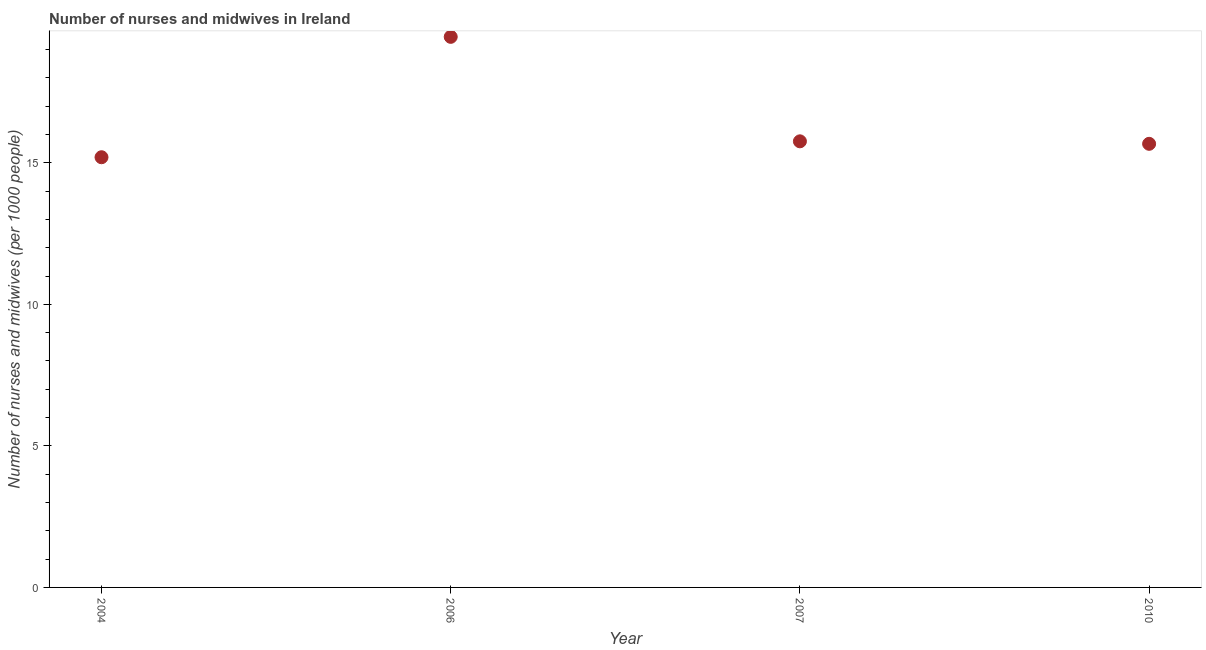What is the number of nurses and midwives in 2007?
Offer a terse response. 15.76. Across all years, what is the maximum number of nurses and midwives?
Ensure brevity in your answer.  19.45. Across all years, what is the minimum number of nurses and midwives?
Your answer should be very brief. 15.2. In which year was the number of nurses and midwives maximum?
Your answer should be very brief. 2006. What is the sum of the number of nurses and midwives?
Ensure brevity in your answer.  66.08. What is the difference between the number of nurses and midwives in 2004 and 2006?
Offer a very short reply. -4.25. What is the average number of nurses and midwives per year?
Ensure brevity in your answer.  16.52. What is the median number of nurses and midwives?
Make the answer very short. 15.71. What is the ratio of the number of nurses and midwives in 2006 to that in 2010?
Offer a very short reply. 1.24. Is the difference between the number of nurses and midwives in 2006 and 2007 greater than the difference between any two years?
Offer a very short reply. No. What is the difference between the highest and the second highest number of nurses and midwives?
Make the answer very short. 3.69. What is the difference between the highest and the lowest number of nurses and midwives?
Your response must be concise. 4.25. How many dotlines are there?
Ensure brevity in your answer.  1. What is the difference between two consecutive major ticks on the Y-axis?
Give a very brief answer. 5. Does the graph contain any zero values?
Make the answer very short. No. What is the title of the graph?
Ensure brevity in your answer.  Number of nurses and midwives in Ireland. What is the label or title of the Y-axis?
Your answer should be very brief. Number of nurses and midwives (per 1000 people). What is the Number of nurses and midwives (per 1000 people) in 2004?
Provide a succinct answer. 15.2. What is the Number of nurses and midwives (per 1000 people) in 2006?
Make the answer very short. 19.45. What is the Number of nurses and midwives (per 1000 people) in 2007?
Keep it short and to the point. 15.76. What is the Number of nurses and midwives (per 1000 people) in 2010?
Ensure brevity in your answer.  15.67. What is the difference between the Number of nurses and midwives (per 1000 people) in 2004 and 2006?
Your answer should be compact. -4.25. What is the difference between the Number of nurses and midwives (per 1000 people) in 2004 and 2007?
Your response must be concise. -0.56. What is the difference between the Number of nurses and midwives (per 1000 people) in 2004 and 2010?
Provide a succinct answer. -0.47. What is the difference between the Number of nurses and midwives (per 1000 people) in 2006 and 2007?
Provide a succinct answer. 3.69. What is the difference between the Number of nurses and midwives (per 1000 people) in 2006 and 2010?
Make the answer very short. 3.78. What is the difference between the Number of nurses and midwives (per 1000 people) in 2007 and 2010?
Your answer should be compact. 0.09. What is the ratio of the Number of nurses and midwives (per 1000 people) in 2004 to that in 2006?
Give a very brief answer. 0.78. What is the ratio of the Number of nurses and midwives (per 1000 people) in 2004 to that in 2007?
Ensure brevity in your answer.  0.96. What is the ratio of the Number of nurses and midwives (per 1000 people) in 2004 to that in 2010?
Your answer should be very brief. 0.97. What is the ratio of the Number of nurses and midwives (per 1000 people) in 2006 to that in 2007?
Provide a succinct answer. 1.23. What is the ratio of the Number of nurses and midwives (per 1000 people) in 2006 to that in 2010?
Ensure brevity in your answer.  1.24. 